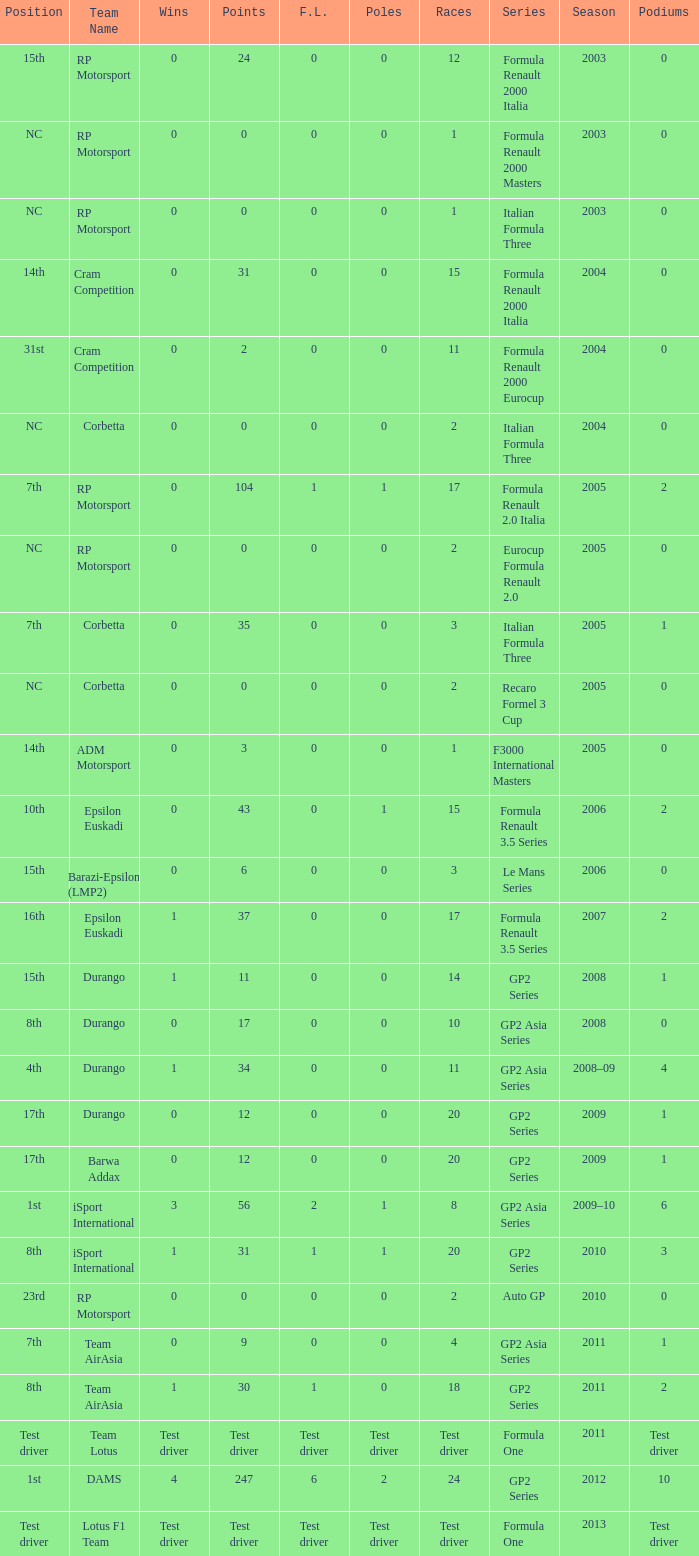What races have gp2 series, 0 F.L. and a 17th position? 20, 20. 